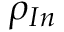<formula> <loc_0><loc_0><loc_500><loc_500>\rho _ { I n } \,</formula> 